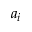Convert formula to latex. <formula><loc_0><loc_0><loc_500><loc_500>a _ { i }</formula> 